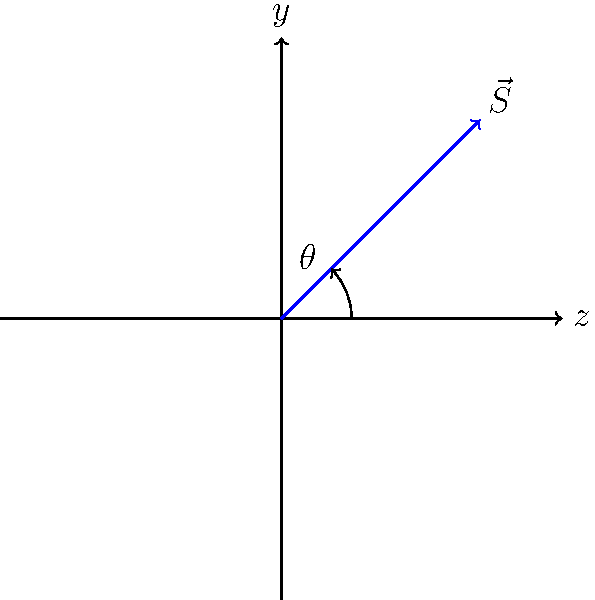In a Stern-Gerlach experiment, a beam of silver atoms is passed through an inhomogeneous magnetic field. The spin angular momentum vector $\vec{S}$ of an electron in a silver atom makes an angle $\theta$ with the z-axis, as shown in the figure. If the probability of measuring the spin-up state ($+\hbar/2$) along the z-axis is 0.85, what is the angle $\theta$ between $\vec{S}$ and the z-axis? To solve this problem, we'll follow these steps:

1) In quantum mechanics, the probability of measuring spin-up along the z-axis is given by $\cos^2(\theta/2)$, where $\theta$ is the angle between the spin vector and the z-axis.

2) We're given that this probability is 0.85. So we can write:

   $\cos^2(\theta/2) = 0.85$

3) To solve for $\theta$, let's first take the square root of both sides:

   $|\cos(\theta/2)| = \sqrt{0.85} \approx 0.9220$

4) Now, we need to take the inverse cosine (arccos) of both sides:

   $\theta/2 = \arccos(0.9220)$

5) Finally, multiply both sides by 2:

   $\theta = 2 \cdot \arccos(0.9220)$

6) Using a calculator or computer, we can evaluate this:

   $\theta \approx 0.5235$ radians

7) Convert to degrees:

   $\theta \approx 0.5235 \cdot \frac{180^{\circ}}{\pi} \approx 30^{\circ}$

Therefore, the angle $\theta$ between $\vec{S}$ and the z-axis is approximately 30°.
Answer: $30^{\circ}$ 